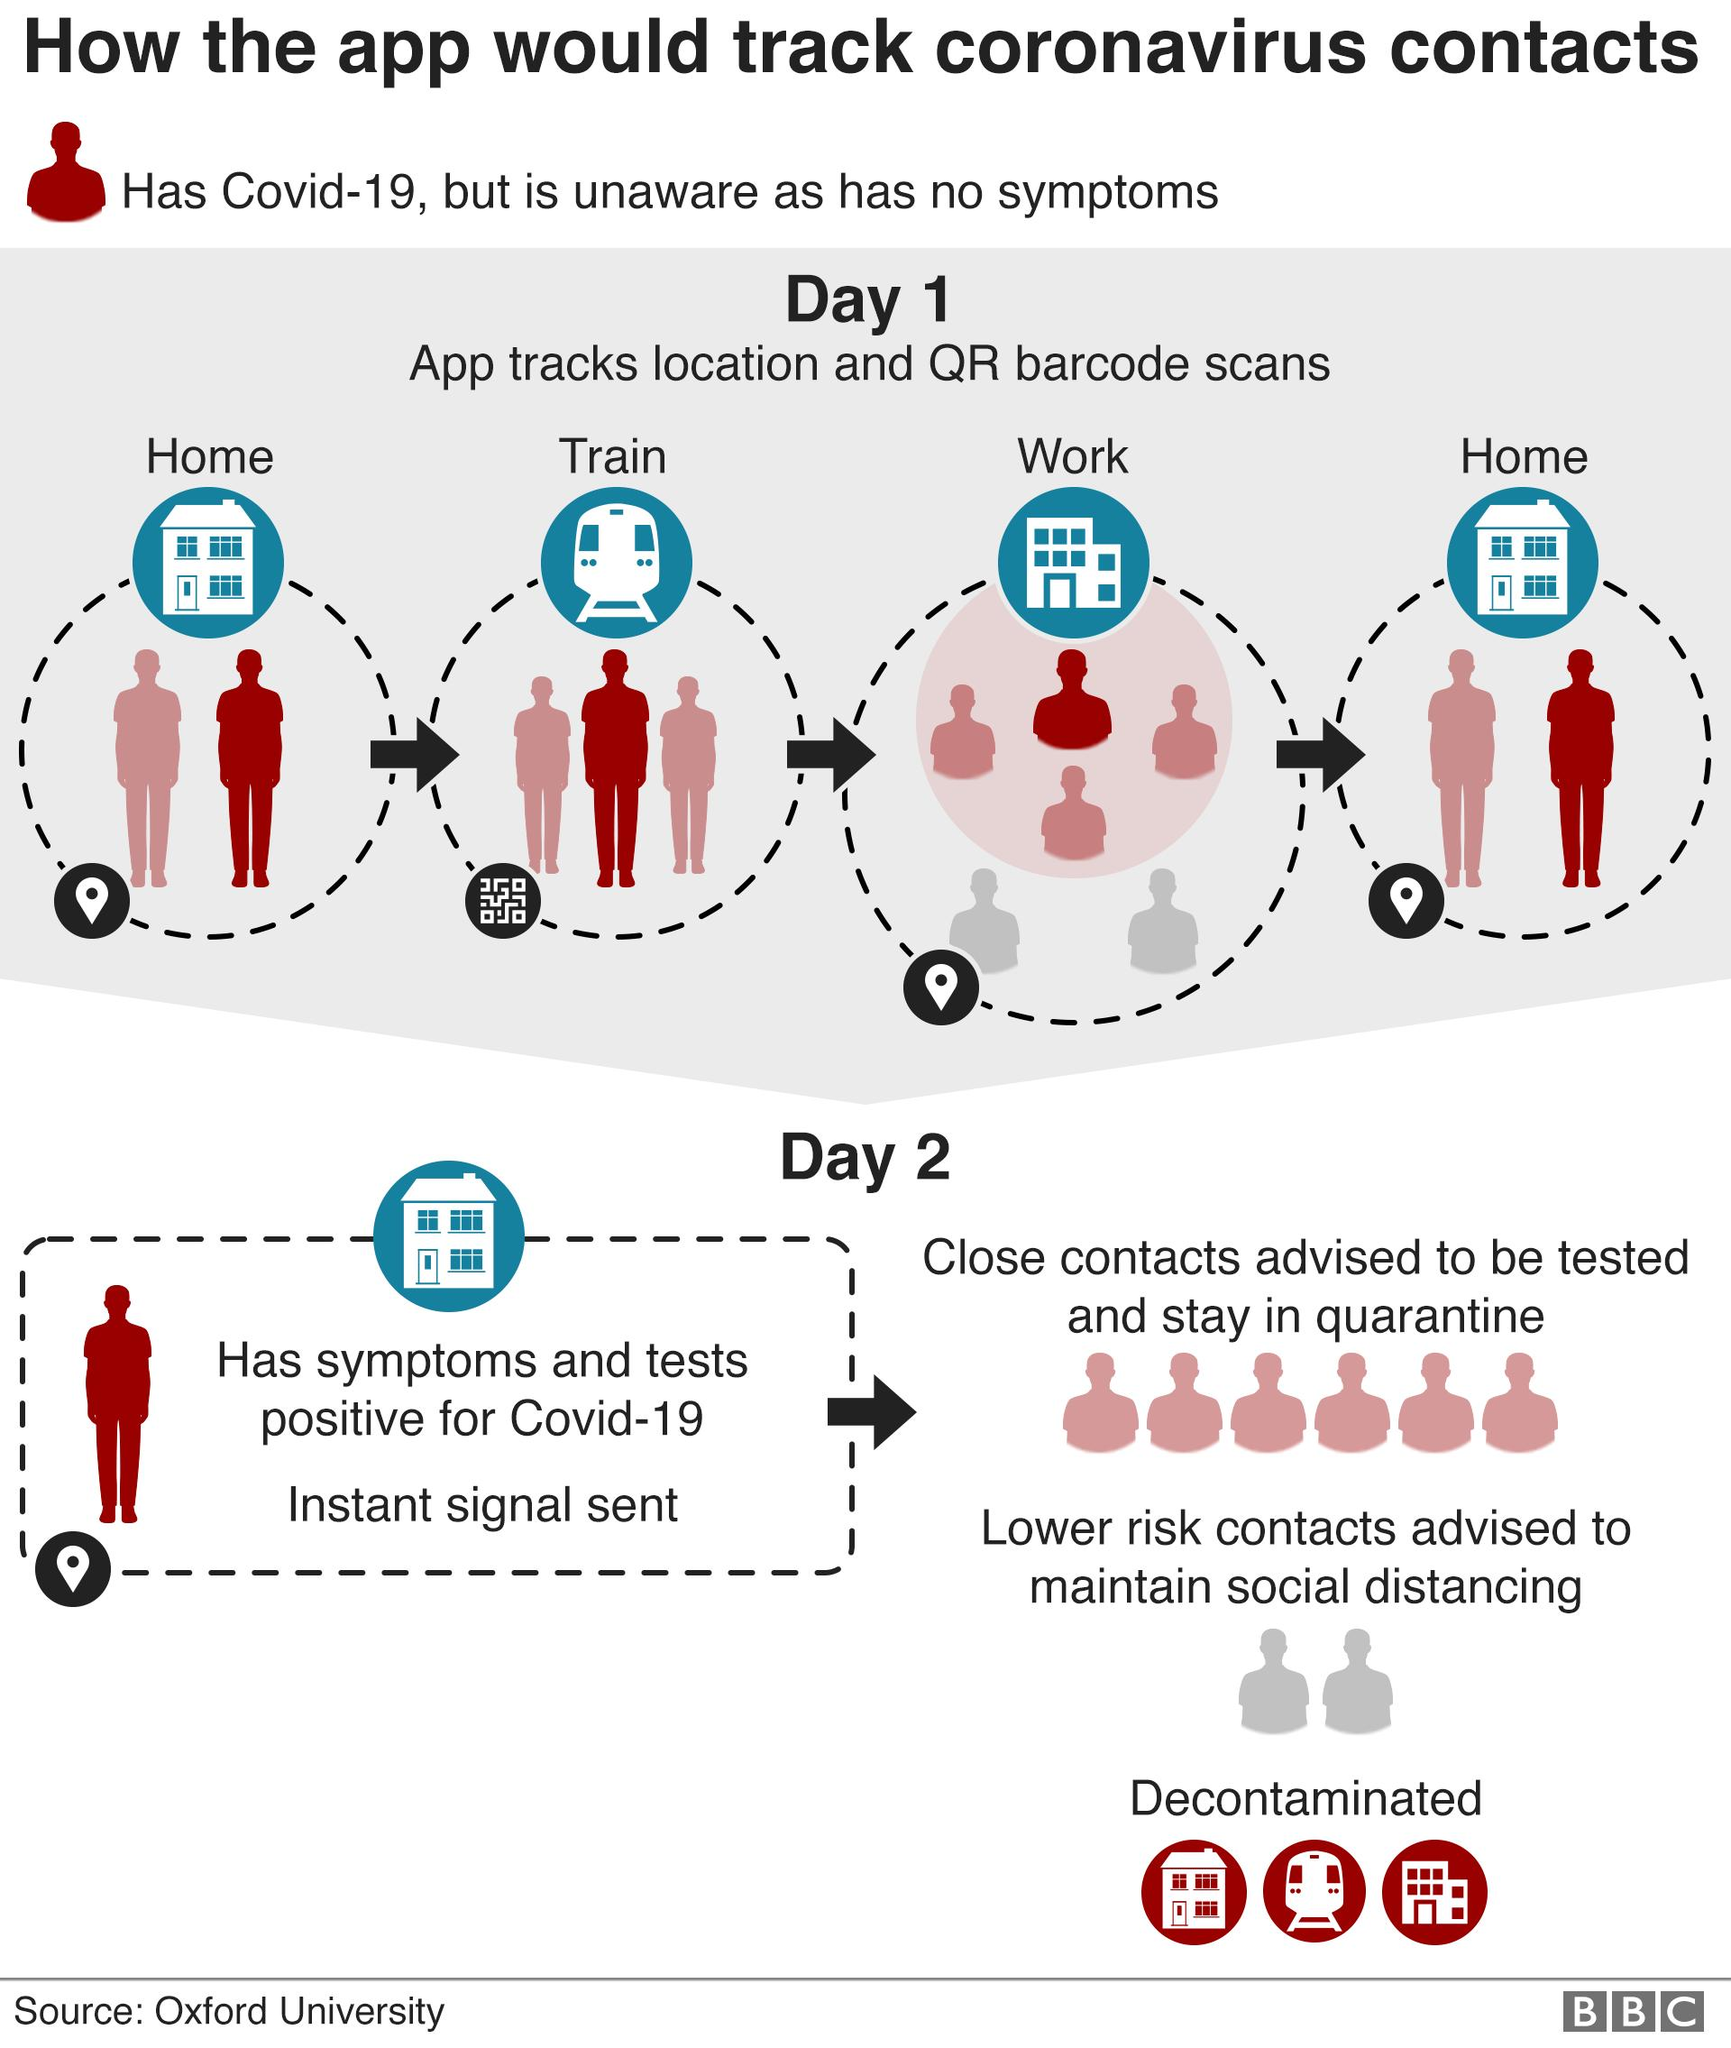Point out several critical features in this image. Close contacts of a person who has symptoms and tests positive for COVID-19 will receive an instant message from the government's contact tracing system. If a person has symptoms and is tested positive for COVID-19, their close contacts and low-risk contacts are identified and managed differently to prevent the spread of the virus. The COVID-19 patient tracking app uses QR code scans to monitor the status of individuals who are currently undergoing training. 